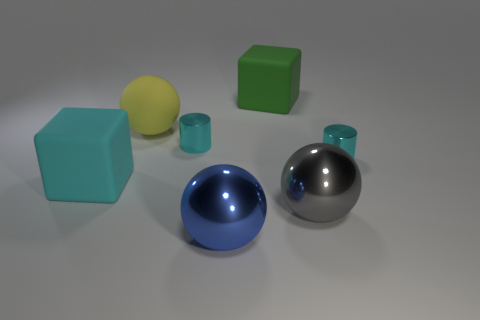What number of tiny shiny cylinders are there?
Provide a short and direct response. 2. Does the cube that is on the right side of the big cyan matte cube have the same material as the gray object?
Offer a terse response. No. What number of big cubes are in front of the big block that is behind the matte object that is to the left of the large yellow rubber thing?
Provide a short and direct response. 1. What is the size of the yellow rubber ball?
Keep it short and to the point. Large. What size is the cyan metallic cylinder that is to the right of the gray metallic ball?
Make the answer very short. Small. Does the metallic cylinder to the left of the green rubber thing have the same color as the tiny shiny cylinder that is on the right side of the big blue thing?
Offer a terse response. Yes. What number of other things are the same shape as the big blue object?
Your answer should be very brief. 2. Are there the same number of large green cubes behind the blue shiny object and big objects on the right side of the large gray metallic sphere?
Offer a very short reply. No. Is the material of the object that is on the left side of the yellow rubber object the same as the cyan cylinder that is left of the big blue ball?
Provide a succinct answer. No. What number of other things are the same size as the cyan rubber block?
Ensure brevity in your answer.  4. 